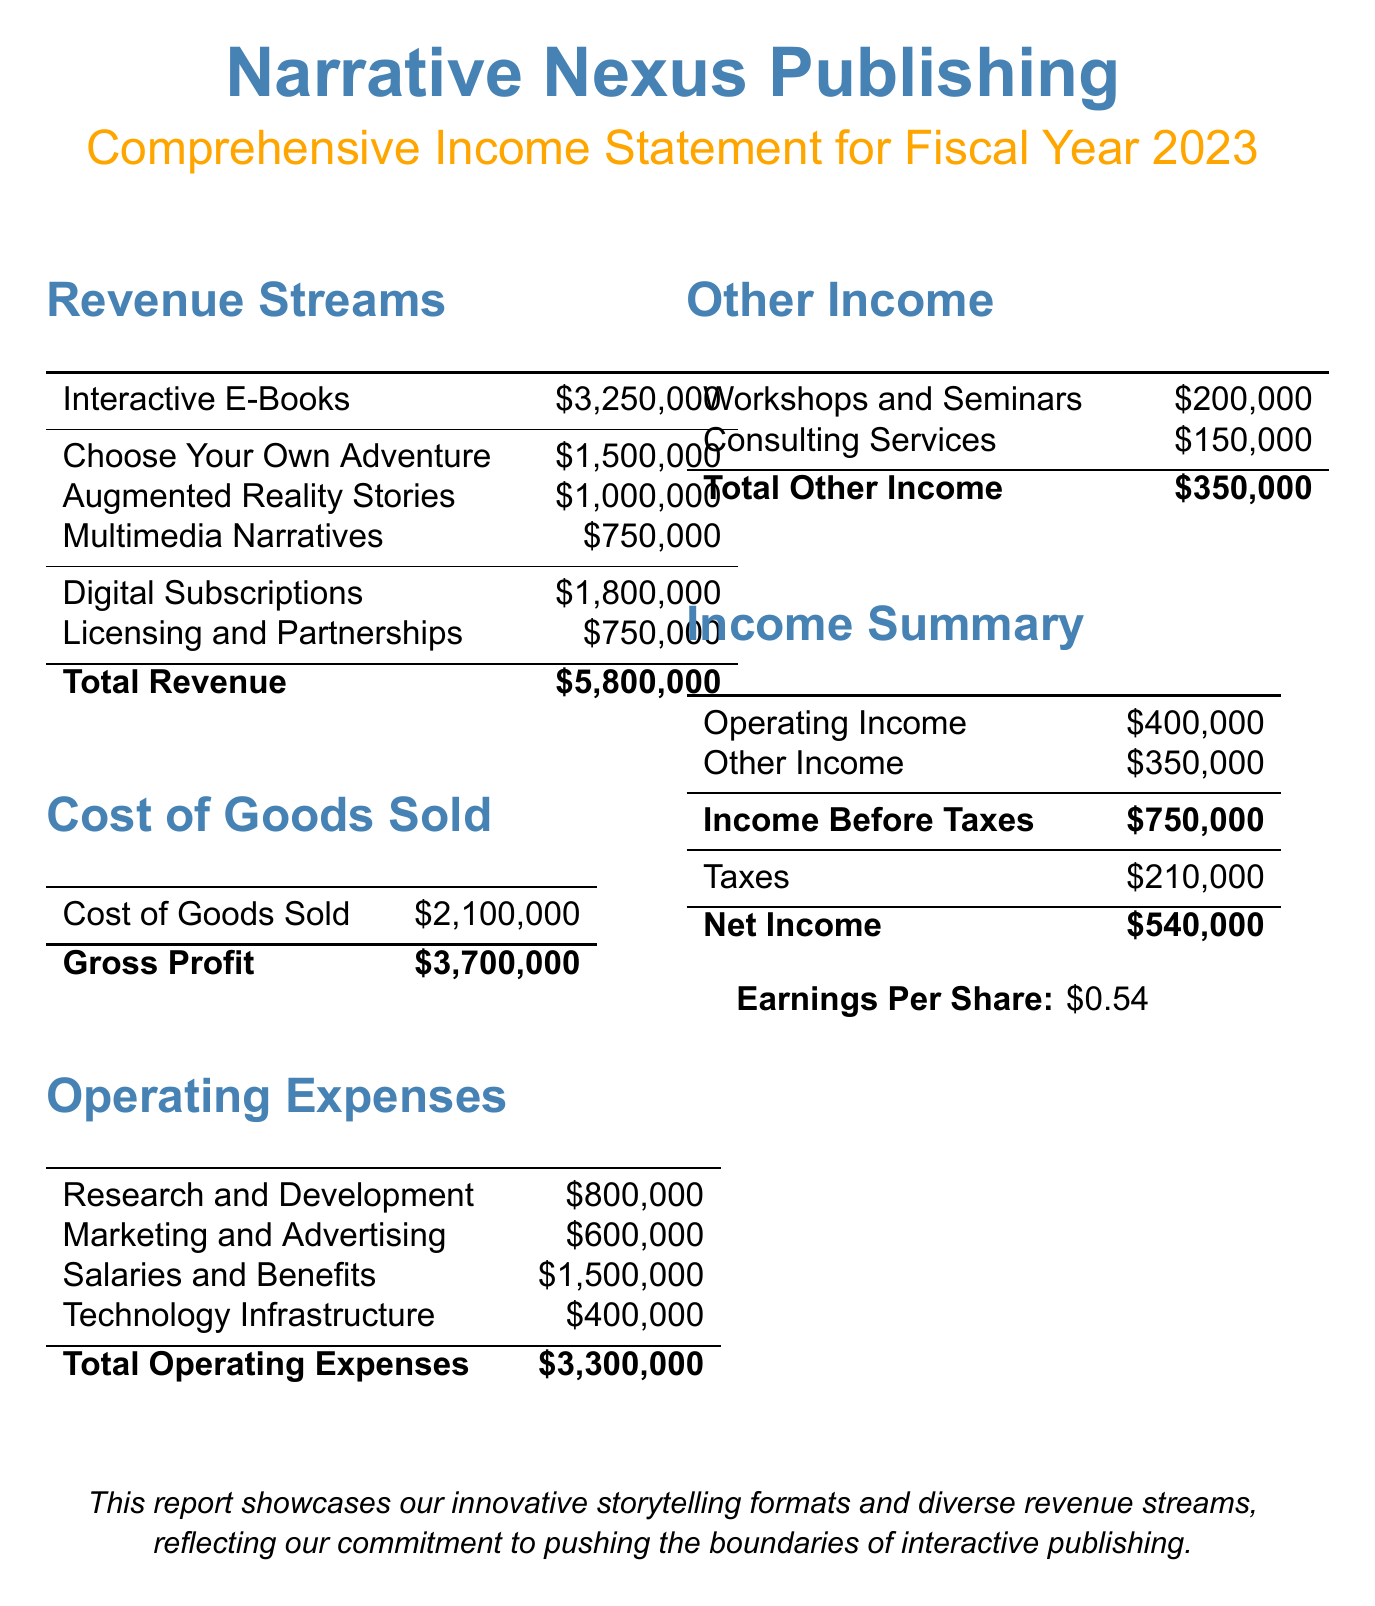What is the total revenue? The total revenue is calculated by adding all revenue streams together, which amounts to $3,250,000 from Interactive E-Books, $1,800,000 from Digital Subscriptions, and $750,000 from Licensing and Partnerships.
Answer: $5,800,000 What is the net income for 2023? The net income is provided in the document as the final profit after all expenses and taxes have been deducted, which is explicitly stated.
Answer: $540,000 How much revenue comes from Choose Your Own Adventure e-books? The document specifies that the revenue from Choose Your Own Adventure is detailed under Interactive E-Books.
Answer: $1,500,000 What is the amount allocated for salaries and benefits? The salaries and benefits expense is one of the operating expenses listed, which specifies the exact amount allocated.
Answer: $1,500,000 What is the total operating expenses? The total operating expenses are the sum of all individual expenses listed under operating expenses, totaling $800,000 + $600,000 + $1,500,000 + $400,000.
Answer: $3,300,000 What percentage of total revenue does Interactive E-Books represent? To find the percentage, the revenue from Interactive E-Books ($3,250,000) is divided by the total revenue ($5,800,000) and then multiplied by 100 to convert to a percentage.
Answer: 56% What is the tax amount stated in the document? The tax amount is provided explicitly in the income summary section of the document.
Answer: $210,000 How much income does the company generate from workshops and seminars? Workshops and seminars are listed as a source of other income in the document, indicating the specified revenue.
Answer: $200,000 What is the earnings per share for Narrative Nexus Publishing? The earnings per share are provided towards the end of the document, showing the value directly stated.
Answer: $0.54 